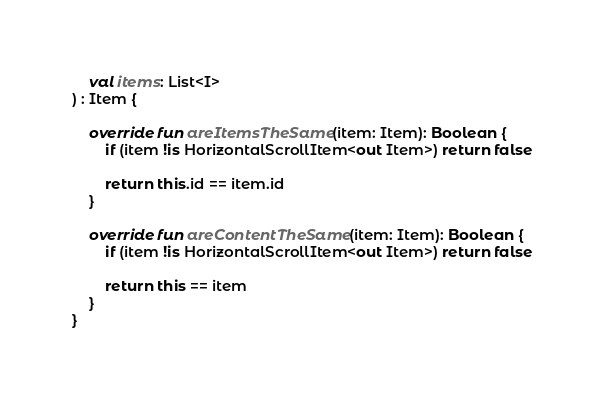<code> <loc_0><loc_0><loc_500><loc_500><_Kotlin_>    val items: List<I>
) : Item {

    override fun areItemsTheSame(item: Item): Boolean {
        if (item !is HorizontalScrollItem<out Item>) return false

        return this.id == item.id
    }

    override fun areContentTheSame(item: Item): Boolean {
        if (item !is HorizontalScrollItem<out Item>) return false

        return this == item
    }
}
</code> 